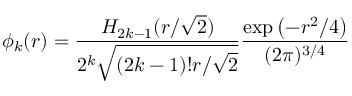<formula> <loc_0><loc_0><loc_500><loc_500>\phi _ { k } ( r ) = \frac { H _ { 2 k - 1 } ( r / \sqrt { 2 } ) } { 2 ^ { k } \sqrt { ( 2 k - 1 ) ! r / \sqrt { 2 } } } \frac { \exp \left ( - r ^ { 2 } / 4 \right ) } { ( 2 \pi ) ^ { 3 / 4 } }</formula> 